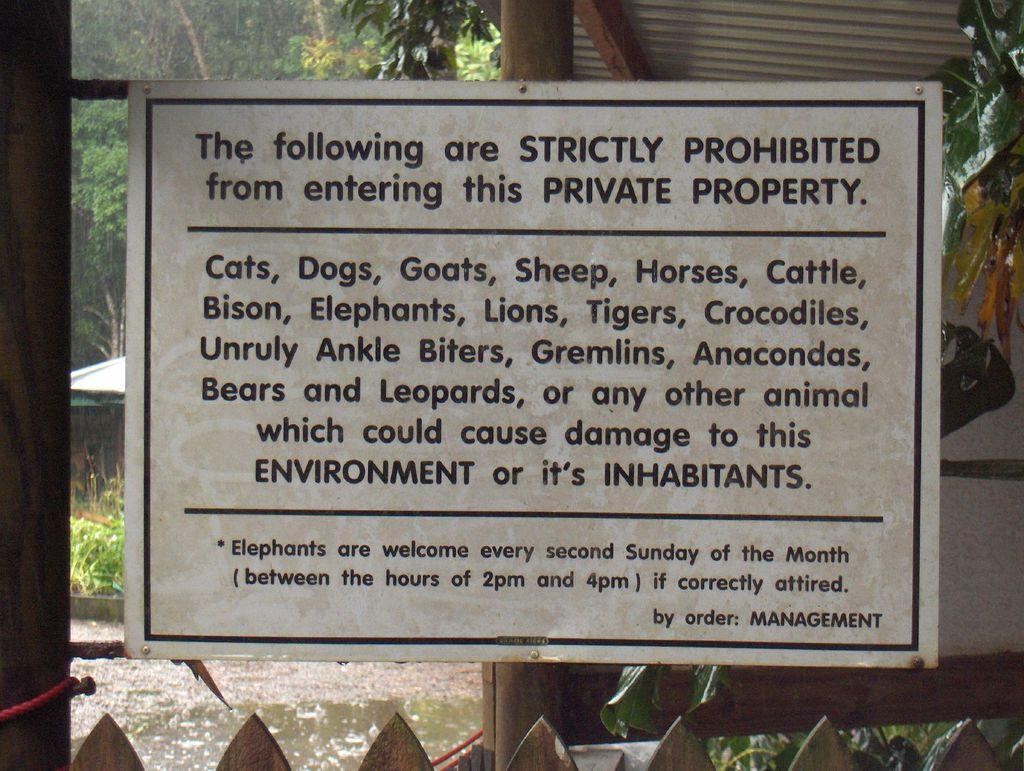Describe this image in one or two sentences. Here we can see a board and poles. In the background there are trees. 